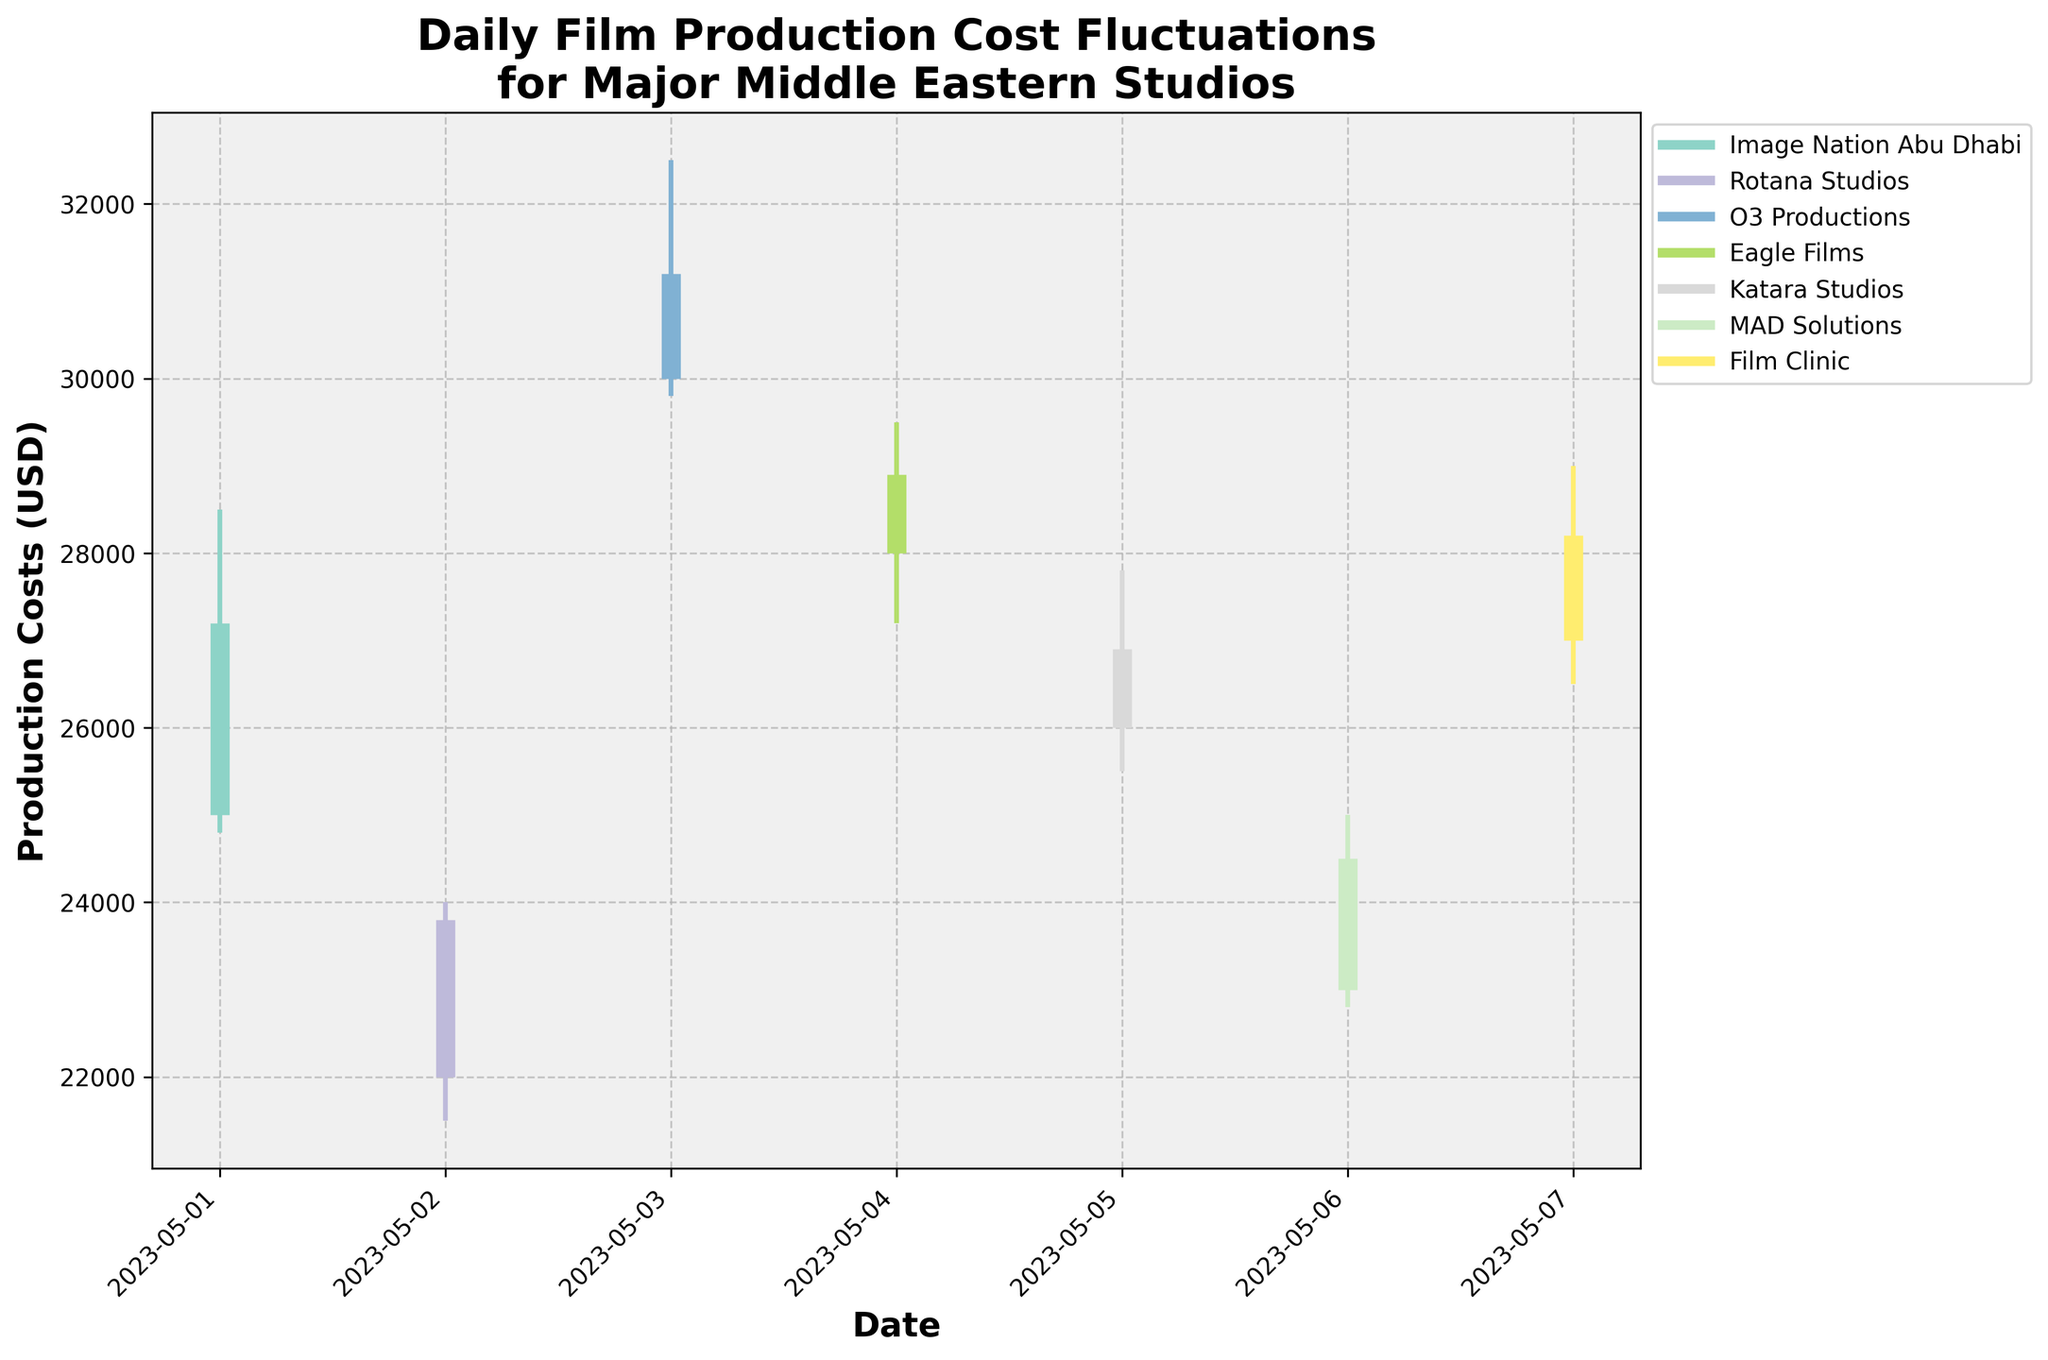what does the x-axis represent? The x-axis represents the dates over which the film production costs are tracked. Each tick mark on the x-axis corresponds to a specific date from 2023-05-01 to 2023-05-07.
Answer: Dates what do the colors in the chart signify? Each color in the chart corresponds to a different film production studio. This distinction helps viewers easily identify the data associated with each studio.
Answer: Different studios which studio had the highest fluctuation in production costs on May 3, 2023? On May 3, 2023, the range of fluctuation between the high and low production costs for O3 Productions is calculated. The high was 32500 and the low was 29800. The extent of fluctuation is 32500 - 29800 = 2700, which is the highest on that date.
Answer: O3 Productions how does the range of crew salaries for MAD Solutions on May 6, 2023, compare to the range for Katara Studios on May 5, 2023? Calculate the fluctuation range for both studios. For MAD Solutions on May 6, 2023, the range is 25000 - 22800 = 2200. For Katara Studios on May 5, 2023, it is 27800 - 25500 = 2300. 2300 is greater than 2200, so Katara Studios had a higher range.
Answer: Katara Studios had a higher range what is the typical pattern in production costs closing values from May 1 to May 7 across the studios? Analyze the closing values for each studio from May 1 to May 7: Image Nation Abu Dhabi (27200), Rotana Studios (23800), O3 Productions (31200), Eagle Films (28900), Katara Studios (26900), MAD Solutions (24500), Film Clinic (28200). The pattern indicates that closing values vary but generally fall within the 23000-32000 range with some studios having peaks and dips.
Answer: General variation within 23000-32000 range which day had the highest opening production cost and which studio was responsible for it? The highest opening cost is found by comparing all the opening values: 25000, 22000, 30000, 28000, 26000, 23000, 27000. The highest value is 30000 on May 3, 2023, by O3 Productions.
Answer: May 3, 2023, O3 Productions how does the average production cost closing value of Eagle Films compare with the average of Rotana Studios from May 1 to May 7? Calculate the average closing values: For Eagle Films, the closing value is 28900. For Rotana Studios, it is 23800. The average for Eagle Films (28900) is higher than for Rotana Studios (23800).
Answer: Eagle Films is higher which studio had the smallest difference between the opening and closing costs on any given day, and what was the amount? Calculate the differences for all studios: Image Nation Abu Dhabi (27200-25000 = 2200), Rotana Studios (23800-22000 = 1800), O3 Productions (31200-30000 = 1200), Eagle Films (28900-28000 = 900), Katara Studios (26900-26000 = 900), MAD Solutions (24500-23000 = 1500), Film Clinic (28200-27000 = 1200). The smallest difference is for Eagle Films and Katara Studios, both with a difference of 900.
Answer: Eagle Films and Katara Studios, 900 